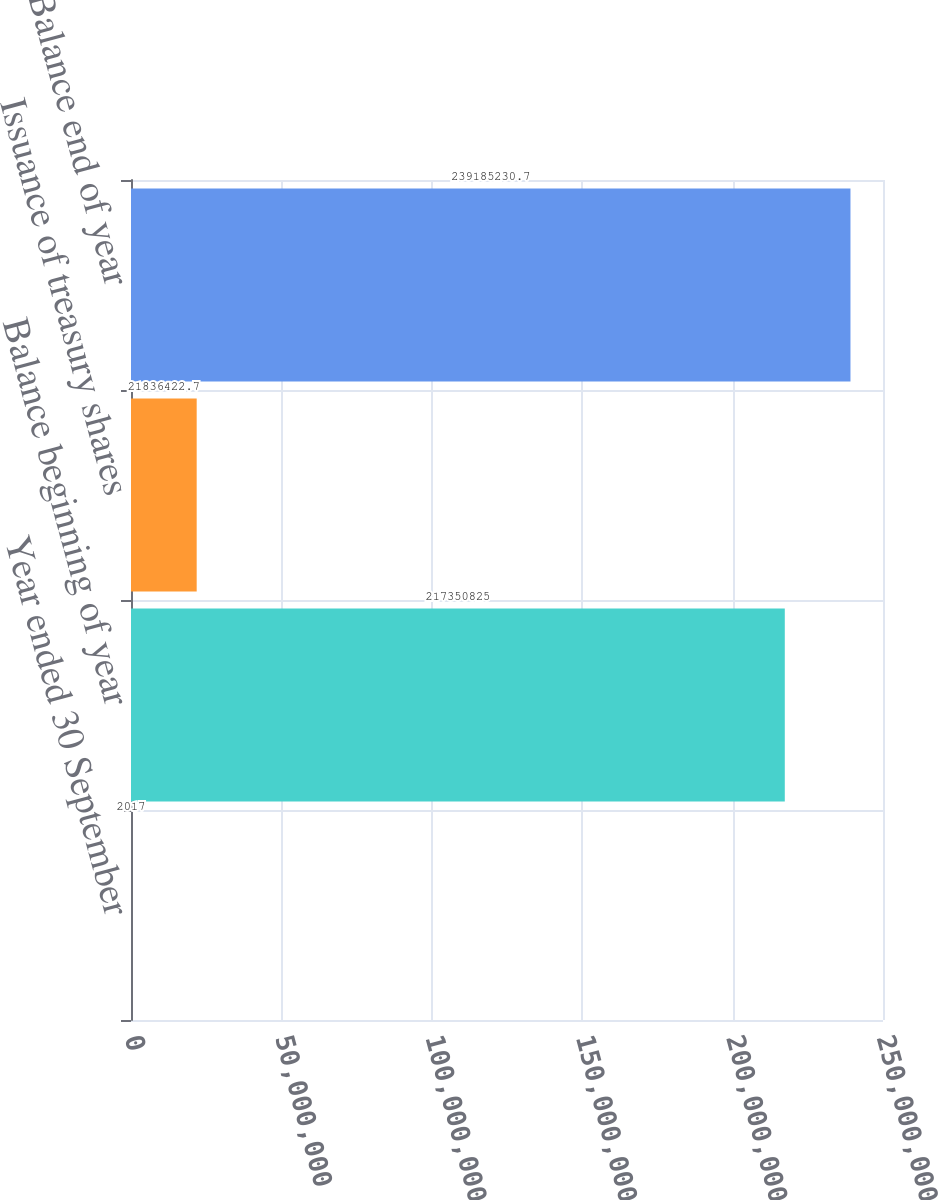Convert chart to OTSL. <chart><loc_0><loc_0><loc_500><loc_500><bar_chart><fcel>Year ended 30 September<fcel>Balance beginning of year<fcel>Issuance of treasury shares<fcel>Balance end of year<nl><fcel>2017<fcel>2.17351e+08<fcel>2.18364e+07<fcel>2.39185e+08<nl></chart> 